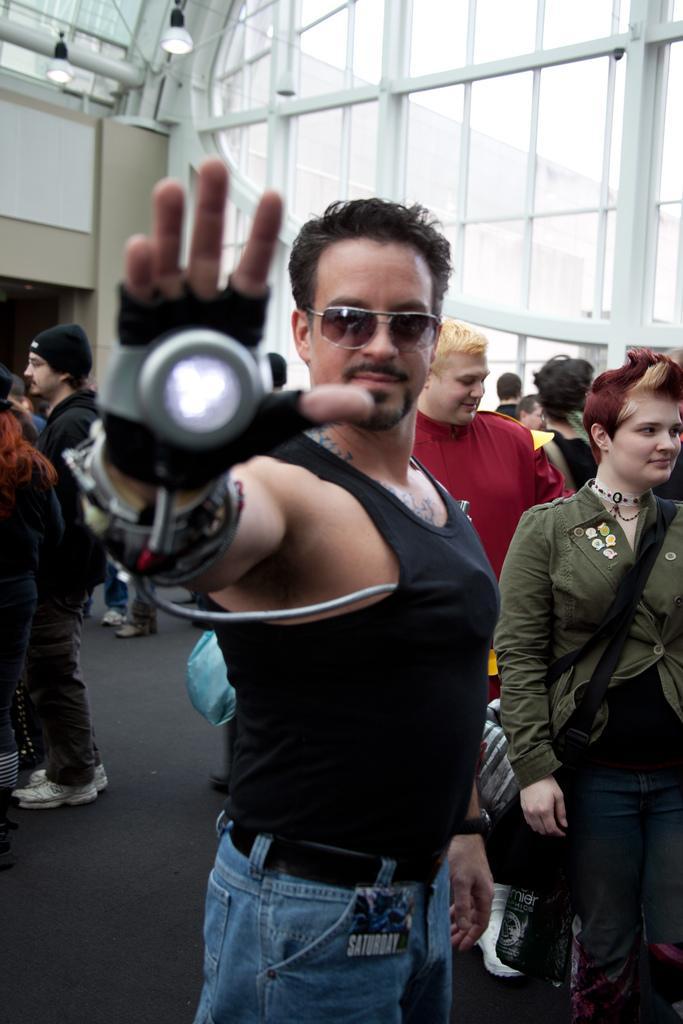Could you give a brief overview of what you see in this image? In this image, we can see many people and one of them is wearing a morpher. In the background, there are windows and lights to a wall. At the bottom, there is a floor. 